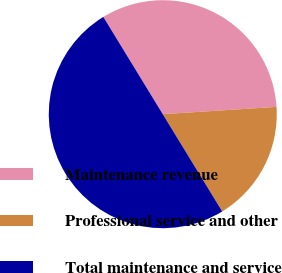Convert chart. <chart><loc_0><loc_0><loc_500><loc_500><pie_chart><fcel>Maintenance revenue<fcel>Professional service and other<fcel>Total maintenance and service<nl><fcel>32.71%<fcel>17.29%<fcel>50.0%<nl></chart> 